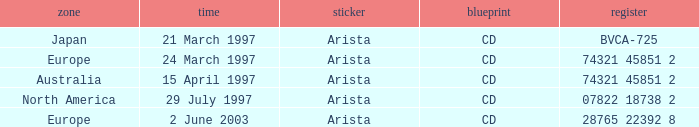What Format has the Region of Europe and a Catalog of 74321 45851 2? CD. 